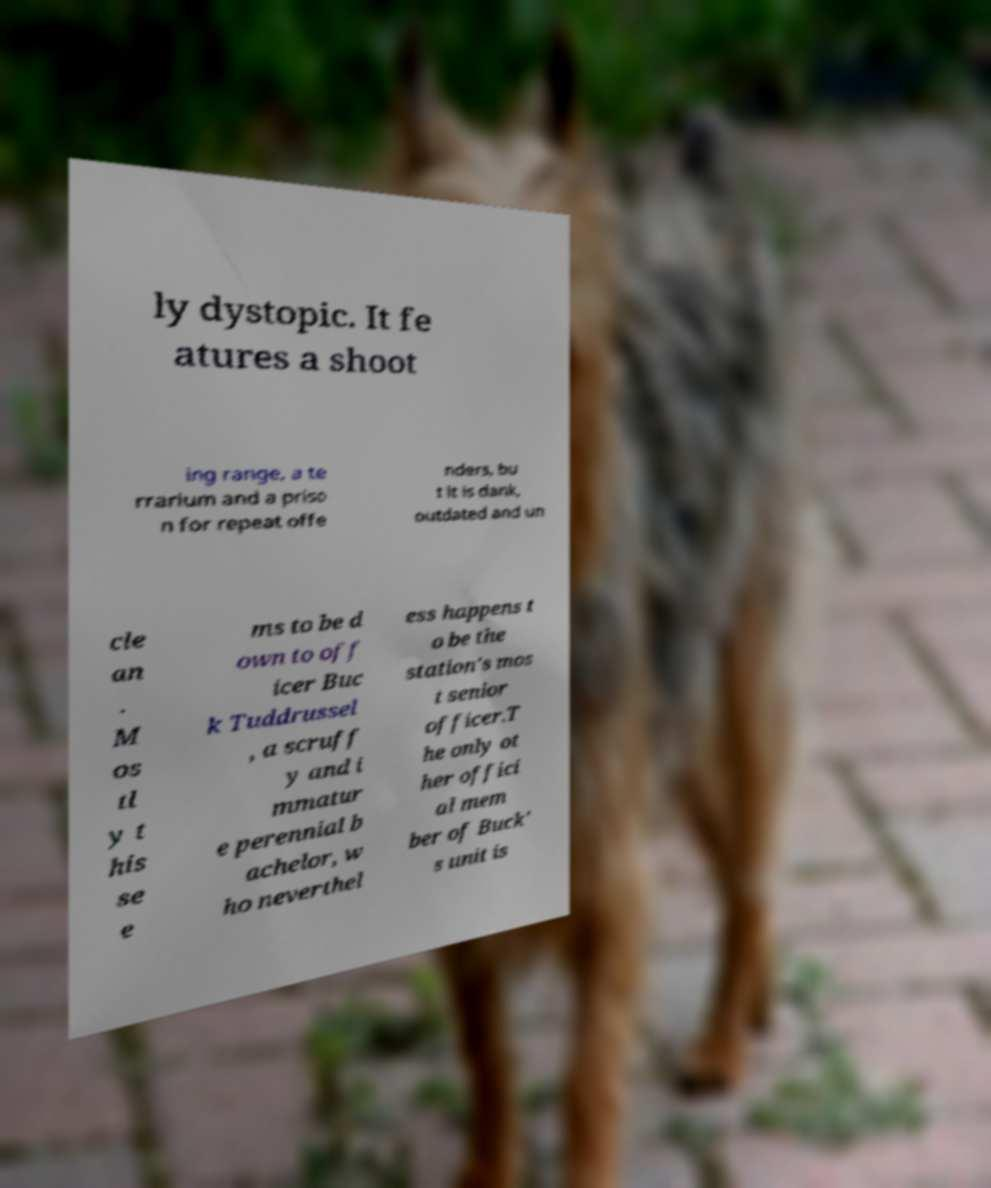For documentation purposes, I need the text within this image transcribed. Could you provide that? ly dystopic. It fe atures a shoot ing range, a te rrarium and a priso n for repeat offe nders, bu t it is dank, outdated and un cle an . M os tl y t his se e ms to be d own to off icer Buc k Tuddrussel , a scruff y and i mmatur e perennial b achelor, w ho neverthel ess happens t o be the station's mos t senior officer.T he only ot her offici al mem ber of Buck' s unit is 